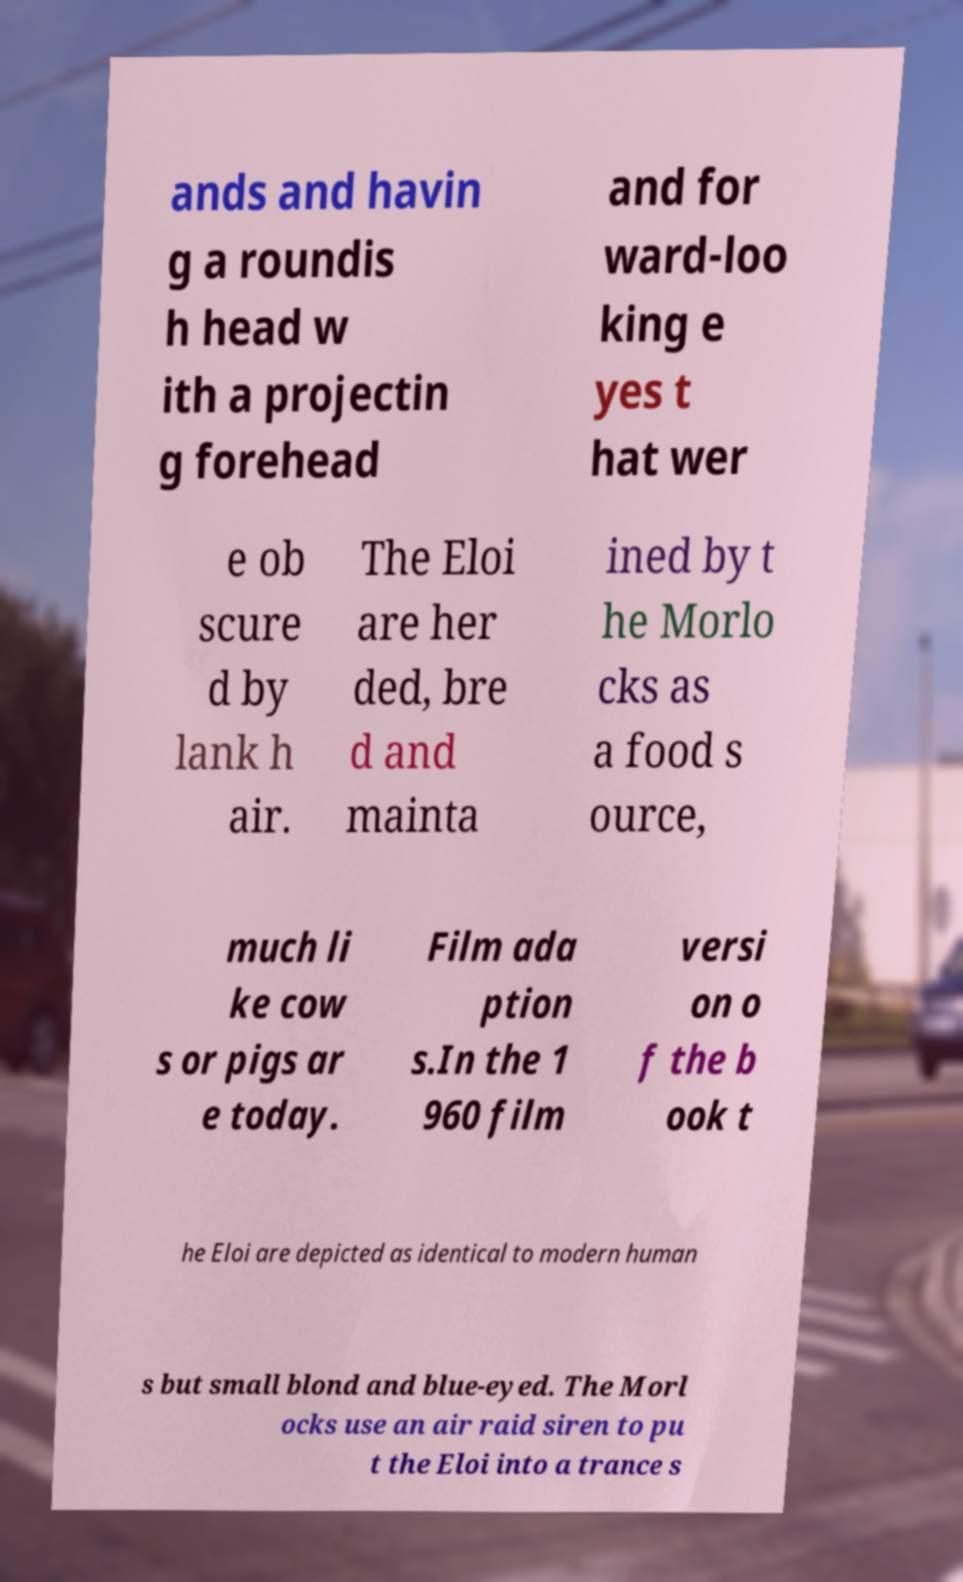Can you accurately transcribe the text from the provided image for me? ands and havin g a roundis h head w ith a projectin g forehead and for ward-loo king e yes t hat wer e ob scure d by lank h air. The Eloi are her ded, bre d and mainta ined by t he Morlo cks as a food s ource, much li ke cow s or pigs ar e today. Film ada ption s.In the 1 960 film versi on o f the b ook t he Eloi are depicted as identical to modern human s but small blond and blue-eyed. The Morl ocks use an air raid siren to pu t the Eloi into a trance s 